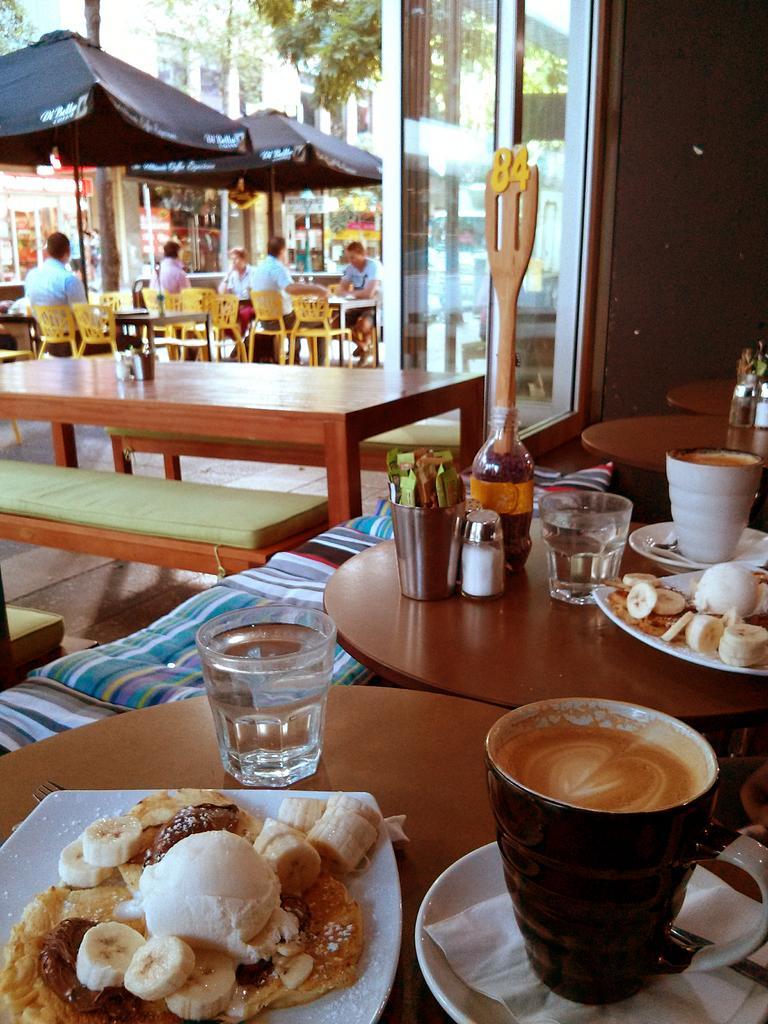How would you summarize this image in a sentence or two? In this picture there is a table on which some food items in the plate were placed. There are some glasses and bottle here. In the background there are some people sitting in the chair in front of their respective tables. We can observe some fabric tents, buildings and trees here. 